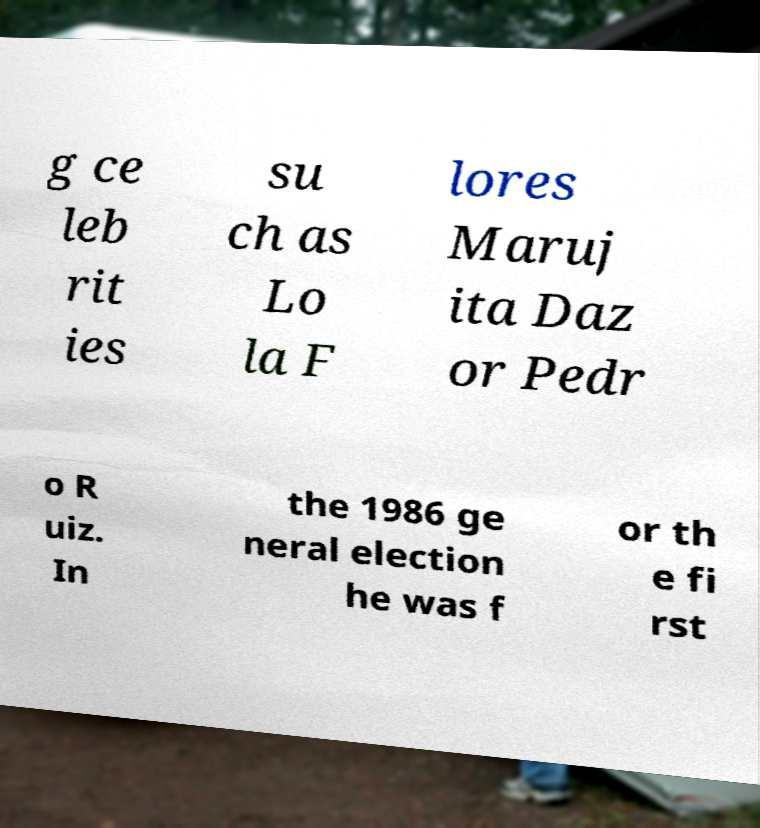For documentation purposes, I need the text within this image transcribed. Could you provide that? g ce leb rit ies su ch as Lo la F lores Maruj ita Daz or Pedr o R uiz. In the 1986 ge neral election he was f or th e fi rst 